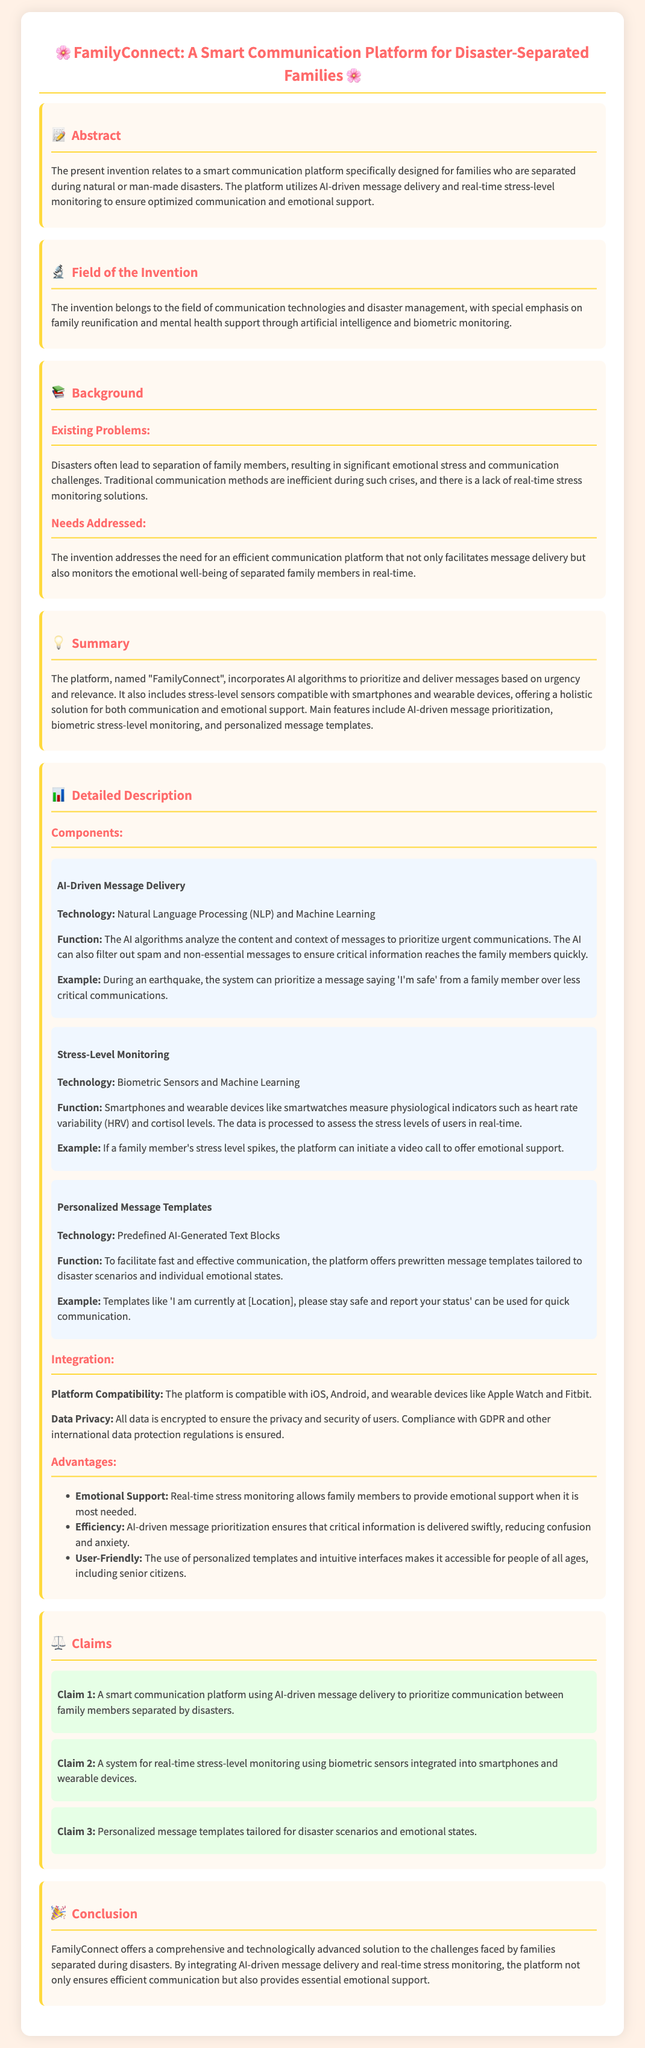what is the title of the patent? The title of the patent indicates the focus of the invention, which is "FamilyConnect: A Smart Communication Platform for Disaster-Separated Families."
Answer: FamilyConnect: A Smart Communication Platform for Disaster-Separated Families what technology is used for message delivery? The document states that Natural Language Processing (NLP) and Machine Learning are the technologies used for AI-driven message delivery.
Answer: Natural Language Processing and Machine Learning what physiological indicators are monitored for stress-level assessment? The document mentions that heart rate variability (HRV) and cortisol levels are the physiological indicators measured by the stress-level monitoring technology.
Answer: Heart rate variability and cortisol levels what is the main function of the Personalized Message Templates component? The component's function is to facilitate fast and effective communication with predefined message templates that are tailored to disaster scenarios and individual emotional states.
Answer: To facilitate fast and effective communication how does the platform ensure user data privacy? The document states that all data is encrypted to ensure the privacy and security of users, ensuring compliance with GDPR and other international data protection regulations.
Answer: All data is encrypted which feature allows family members to provide emotional support in real-time? The real-time stress monitoring feature enables family members to know when emotional support is needed, triggering communication like video calls when stress levels spike.
Answer: Real-time stress monitoring how does the platform prioritize messages? The AI algorithms analyze the content and context of messages to prioritize urgent communications and filter out non-essential messages.
Answer: AI algorithms analyze content and context what is the primary benefit of AI-driven message prioritization? The primary benefit is that it ensures critical information is delivered swiftly, helping to reduce confusion and anxiety during crises.
Answer: Reducing confusion and anxiety how many claims are made in the patent? The document lists three specific claims regarding the functionalities of the smart communication platform.
Answer: Three claims 